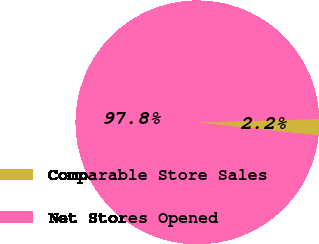<chart> <loc_0><loc_0><loc_500><loc_500><pie_chart><fcel>Comparable Store Sales<fcel>Net Stores Opened<nl><fcel>2.17%<fcel>97.83%<nl></chart> 